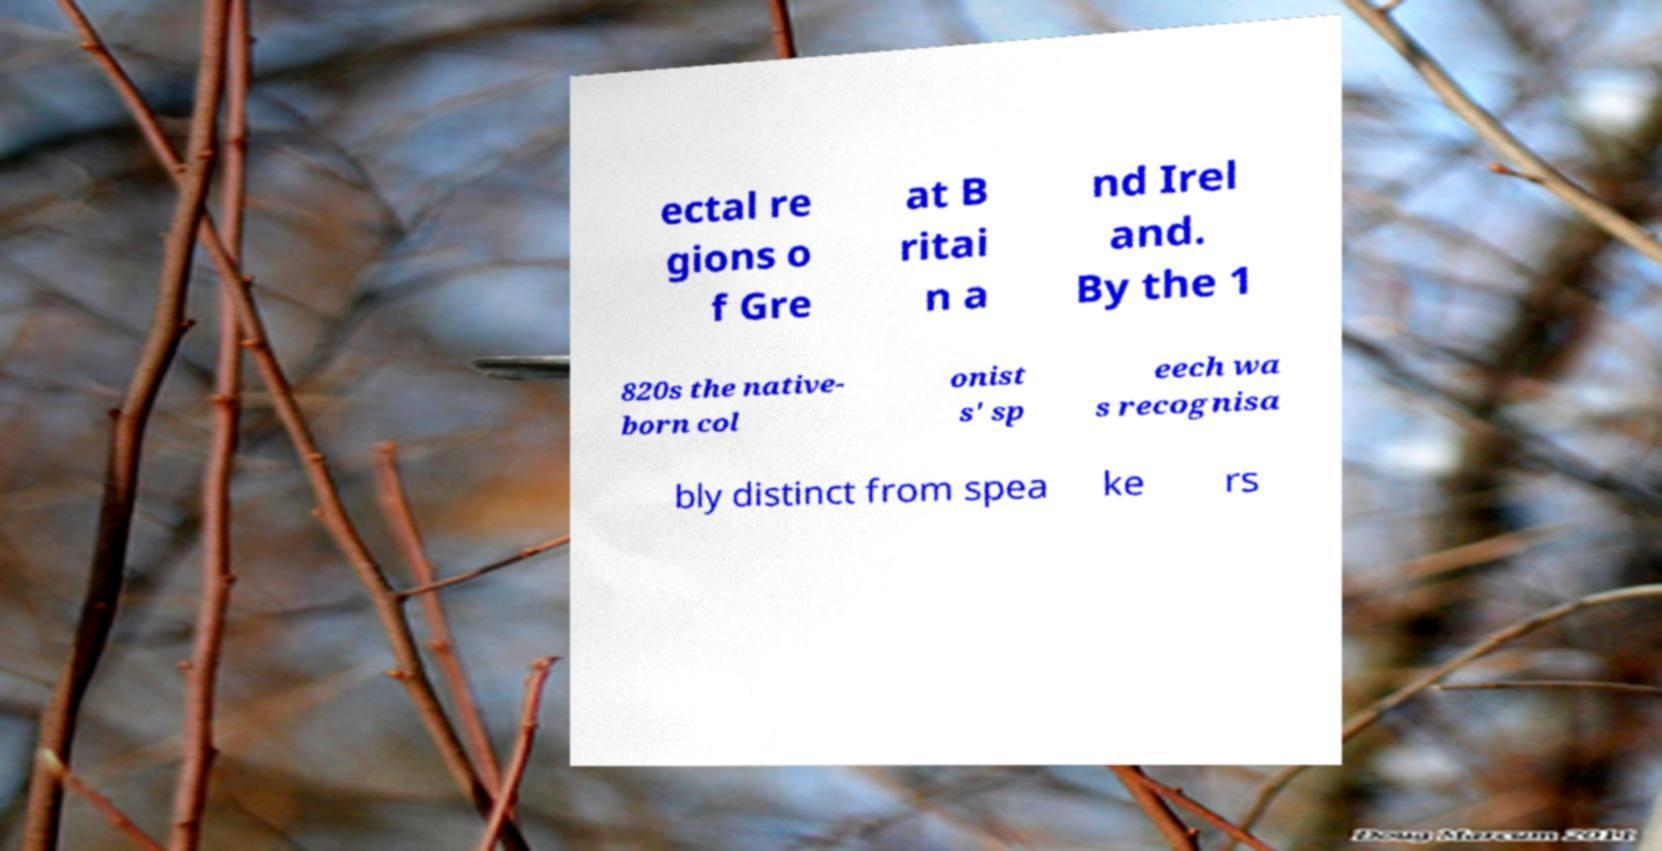What messages or text are displayed in this image? I need them in a readable, typed format. ectal re gions o f Gre at B ritai n a nd Irel and. By the 1 820s the native- born col onist s' sp eech wa s recognisa bly distinct from spea ke rs 